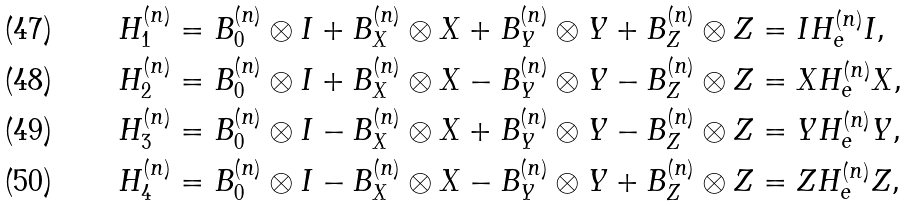<formula> <loc_0><loc_0><loc_500><loc_500>H _ { 1 } ^ { ( n ) } & = B _ { 0 } ^ { ( n ) } \otimes I + B _ { X } ^ { ( n ) } \otimes X + B _ { Y } ^ { ( n ) } \otimes Y + B _ { Z } ^ { ( n ) } \otimes Z = I H _ { e } ^ { ( n ) } I , \\ H _ { 2 } ^ { ( n ) } & = B _ { 0 } ^ { ( n ) } \otimes I + B _ { X } ^ { ( n ) } \otimes X - B _ { Y } ^ { ( n ) } \otimes Y - B _ { Z } ^ { ( n ) } \otimes Z = X H _ { e } ^ { ( n ) } X , \\ H _ { 3 } ^ { ( n ) } & = B _ { 0 } ^ { ( n ) } \otimes I - B _ { X } ^ { ( n ) } \otimes X + B _ { Y } ^ { ( n ) } \otimes Y - B _ { Z } ^ { ( n ) } \otimes Z = Y H _ { e } ^ { ( n ) } Y , \\ H _ { 4 } ^ { ( n ) } & = B _ { 0 } ^ { ( n ) } \otimes I - B _ { X } ^ { ( n ) } \otimes X - B _ { Y } ^ { ( n ) } \otimes Y + B _ { Z } ^ { ( n ) } \otimes Z = Z H _ { e } ^ { ( n ) } Z ,</formula> 